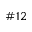<formula> <loc_0><loc_0><loc_500><loc_500>\# 1 2</formula> 